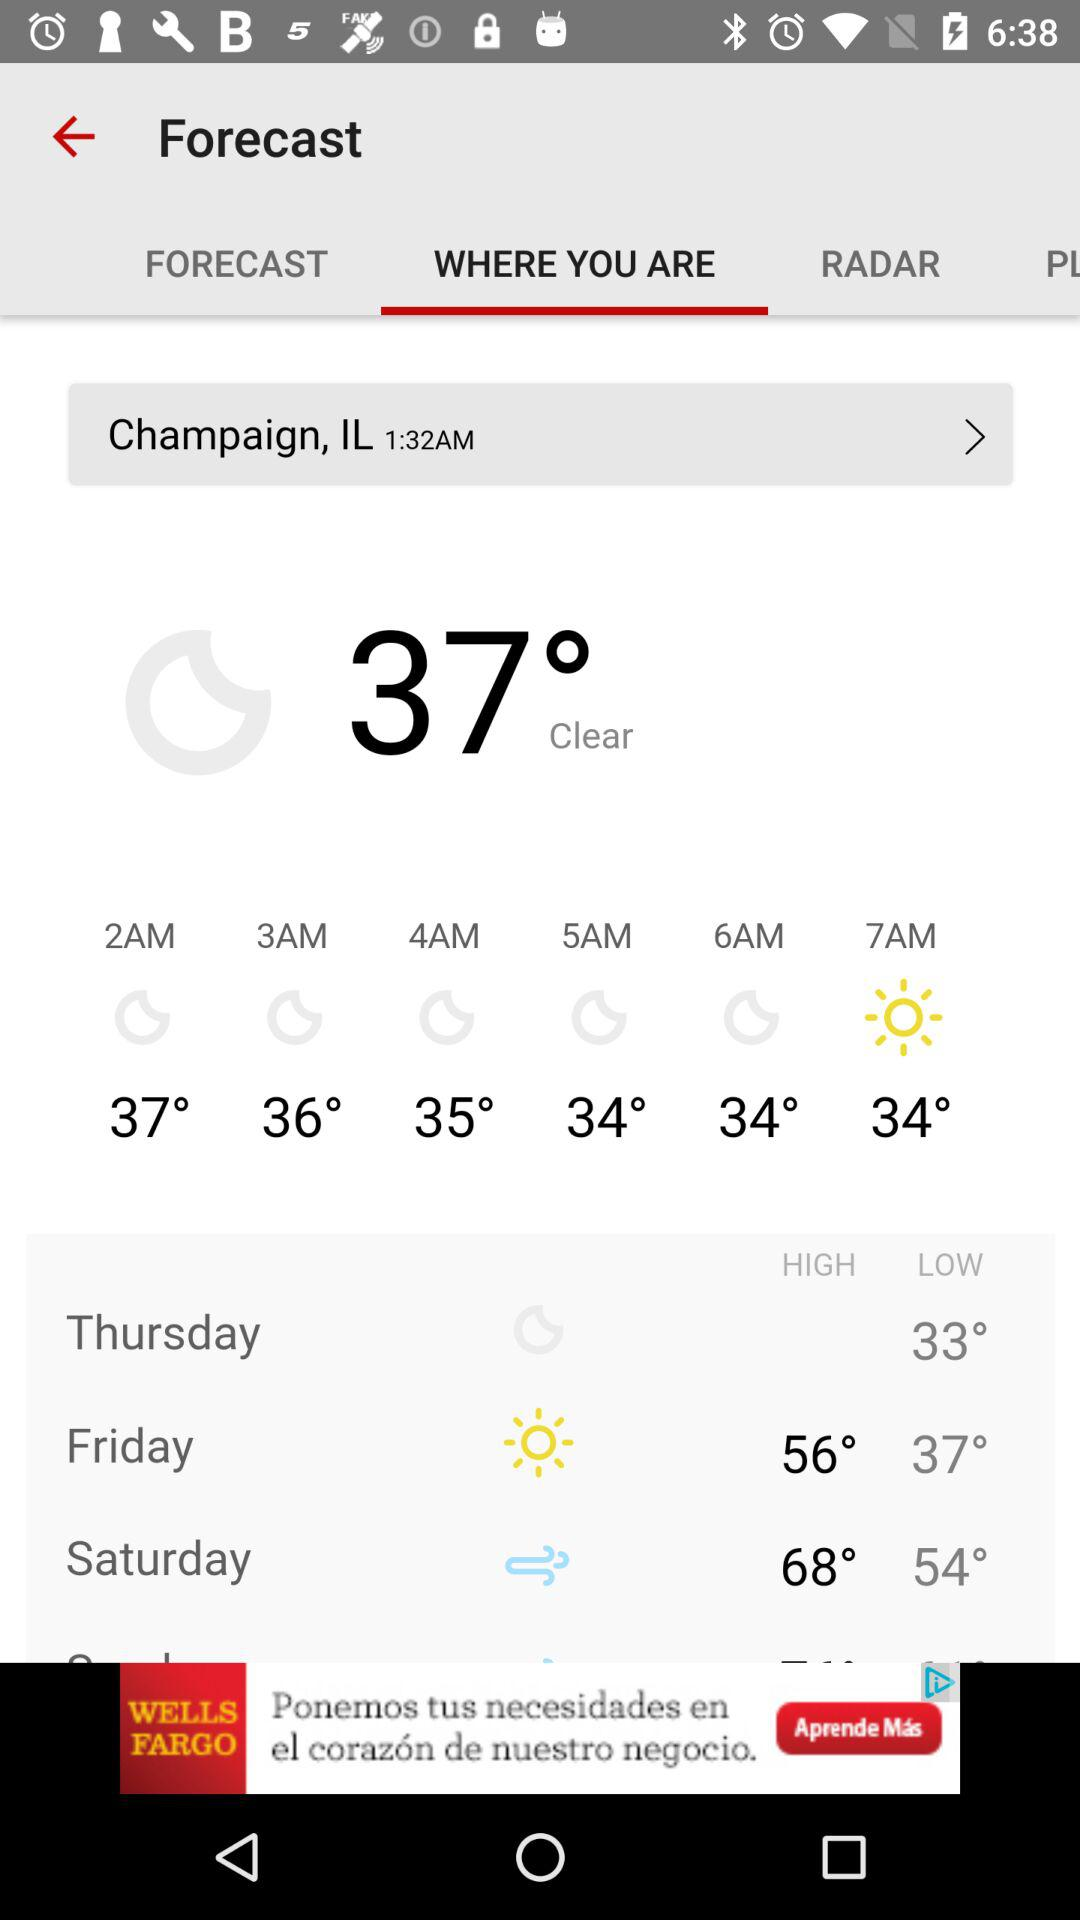How is the weather? The weather is clear. 